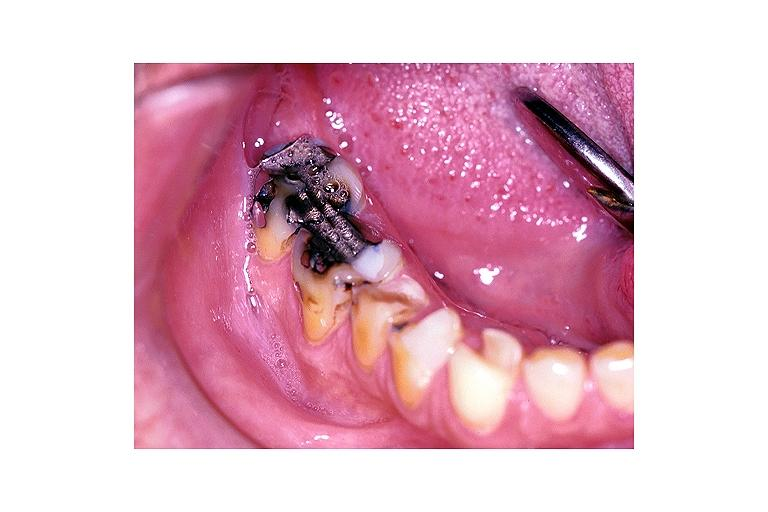does this image show severe abrasion?
Answer the question using a single word or phrase. Yes 